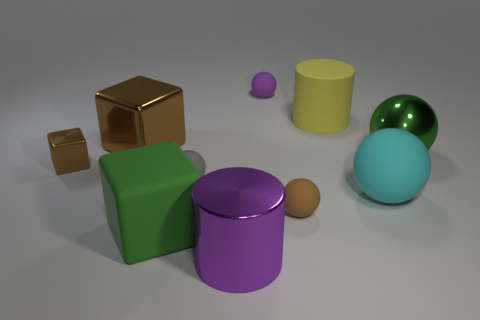There is a sphere that is the same color as the shiny cylinder; what is its size? The sphere sharing the shiny cylinder's color is medium-sized compared to the other objects in the image. 